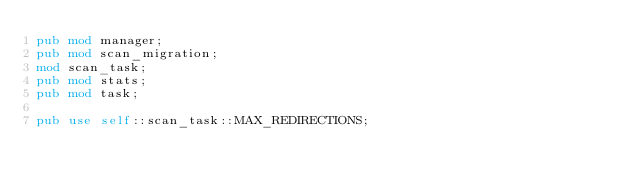Convert code to text. <code><loc_0><loc_0><loc_500><loc_500><_Rust_>pub mod manager;
pub mod scan_migration;
mod scan_task;
pub mod stats;
pub mod task;

pub use self::scan_task::MAX_REDIRECTIONS;
</code> 